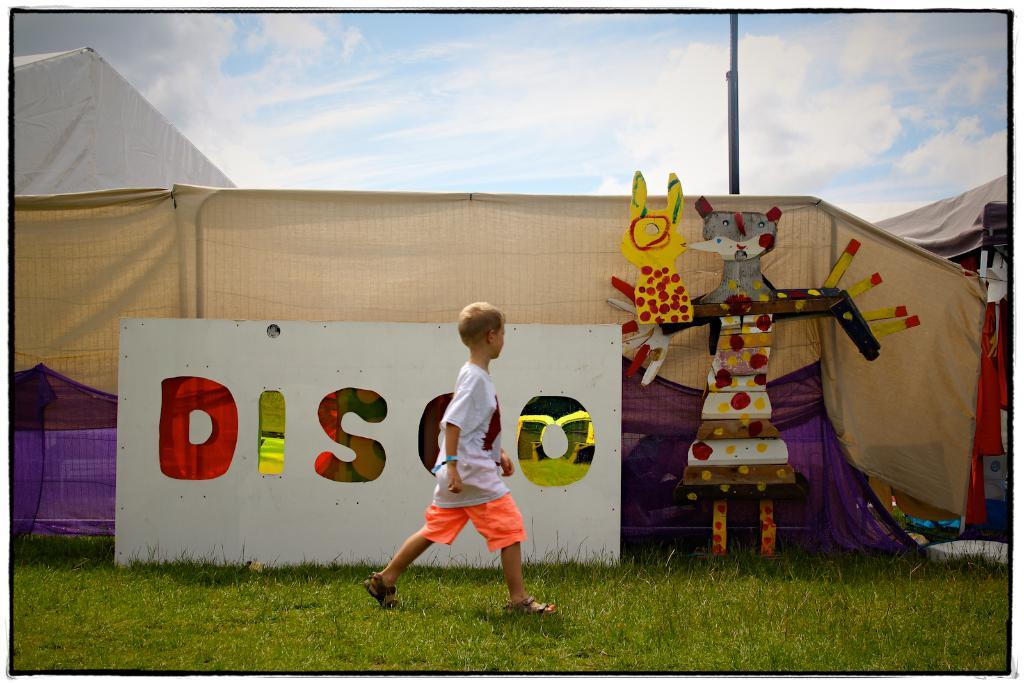<image>
Summarize the visual content of the image. A boy is walking past a sign that says Disco. 